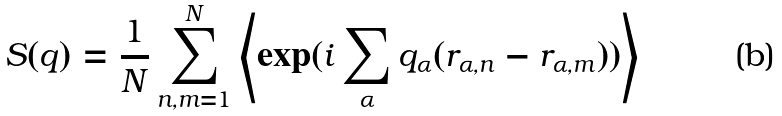<formula> <loc_0><loc_0><loc_500><loc_500>S ( q ) = \frac { 1 } { N } \sum _ { n , m = 1 } ^ { N } \left < \exp ( i \sum _ { \alpha } q _ { \alpha } ( r _ { \alpha , n } - r _ { \alpha , m } ) ) \right ></formula> 